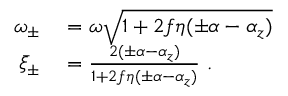Convert formula to latex. <formula><loc_0><loc_0><loc_500><loc_500>\begin{array} { r l } { \omega _ { \pm } } & = \omega \sqrt { 1 + 2 f \eta ( \pm \alpha - \alpha _ { z } ) } } \\ { \bar { \xi } _ { \pm } } & = \frac { 2 ( \pm \alpha - \alpha _ { z } ) } { 1 + 2 f \eta ( \pm \alpha - \alpha _ { z } ) } \ . } \end{array}</formula> 